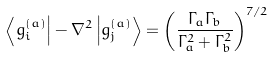Convert formula to latex. <formula><loc_0><loc_0><loc_500><loc_500>\left \langle { g _ { i } ^ { ( a ) } } \right | - \nabla ^ { 2 } \left | { g _ { j } ^ { ( a ) } } \right \rangle = \left ( { \frac { \Gamma _ { a } \Gamma _ { b } } { \Gamma _ { a } ^ { 2 } + \Gamma _ { b } ^ { 2 } } } \right ) ^ { 7 / 2 }</formula> 